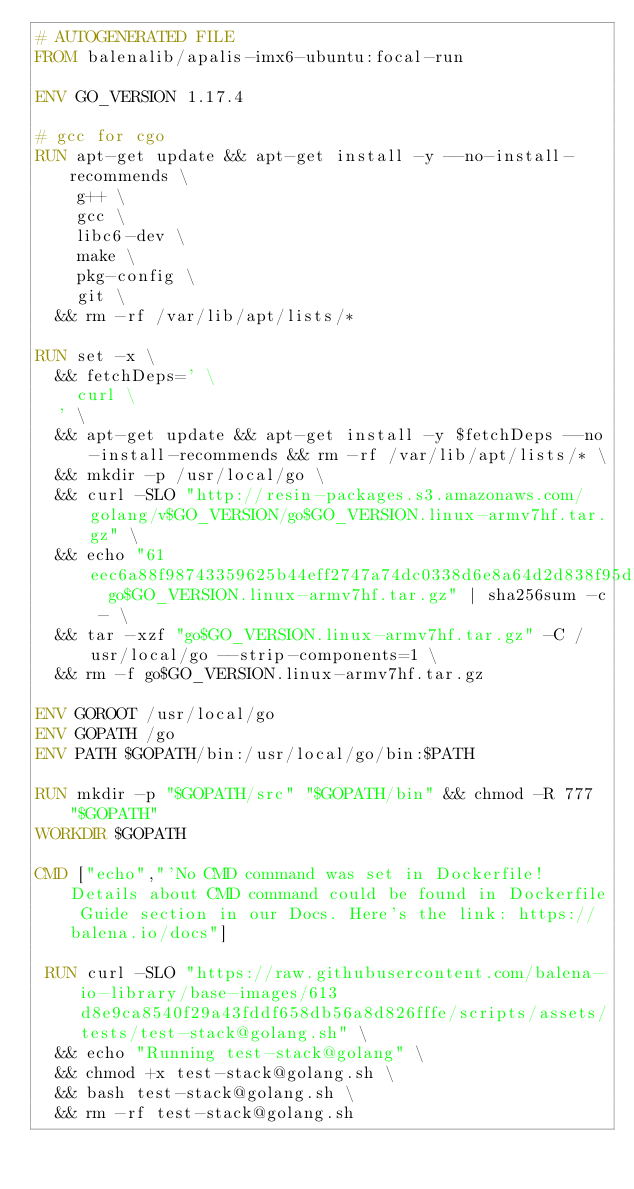Convert code to text. <code><loc_0><loc_0><loc_500><loc_500><_Dockerfile_># AUTOGENERATED FILE
FROM balenalib/apalis-imx6-ubuntu:focal-run

ENV GO_VERSION 1.17.4

# gcc for cgo
RUN apt-get update && apt-get install -y --no-install-recommends \
		g++ \
		gcc \
		libc6-dev \
		make \
		pkg-config \
		git \
	&& rm -rf /var/lib/apt/lists/*

RUN set -x \
	&& fetchDeps=' \
		curl \
	' \
	&& apt-get update && apt-get install -y $fetchDeps --no-install-recommends && rm -rf /var/lib/apt/lists/* \
	&& mkdir -p /usr/local/go \
	&& curl -SLO "http://resin-packages.s3.amazonaws.com/golang/v$GO_VERSION/go$GO_VERSION.linux-armv7hf.tar.gz" \
	&& echo "61eec6a88f98743359625b44eff2747a74dc0338d6e8a64d2d838f95dbd7050d  go$GO_VERSION.linux-armv7hf.tar.gz" | sha256sum -c - \
	&& tar -xzf "go$GO_VERSION.linux-armv7hf.tar.gz" -C /usr/local/go --strip-components=1 \
	&& rm -f go$GO_VERSION.linux-armv7hf.tar.gz

ENV GOROOT /usr/local/go
ENV GOPATH /go
ENV PATH $GOPATH/bin:/usr/local/go/bin:$PATH

RUN mkdir -p "$GOPATH/src" "$GOPATH/bin" && chmod -R 777 "$GOPATH"
WORKDIR $GOPATH

CMD ["echo","'No CMD command was set in Dockerfile! Details about CMD command could be found in Dockerfile Guide section in our Docs. Here's the link: https://balena.io/docs"]

 RUN curl -SLO "https://raw.githubusercontent.com/balena-io-library/base-images/613d8e9ca8540f29a43fddf658db56a8d826fffe/scripts/assets/tests/test-stack@golang.sh" \
  && echo "Running test-stack@golang" \
  && chmod +x test-stack@golang.sh \
  && bash test-stack@golang.sh \
  && rm -rf test-stack@golang.sh 
</code> 